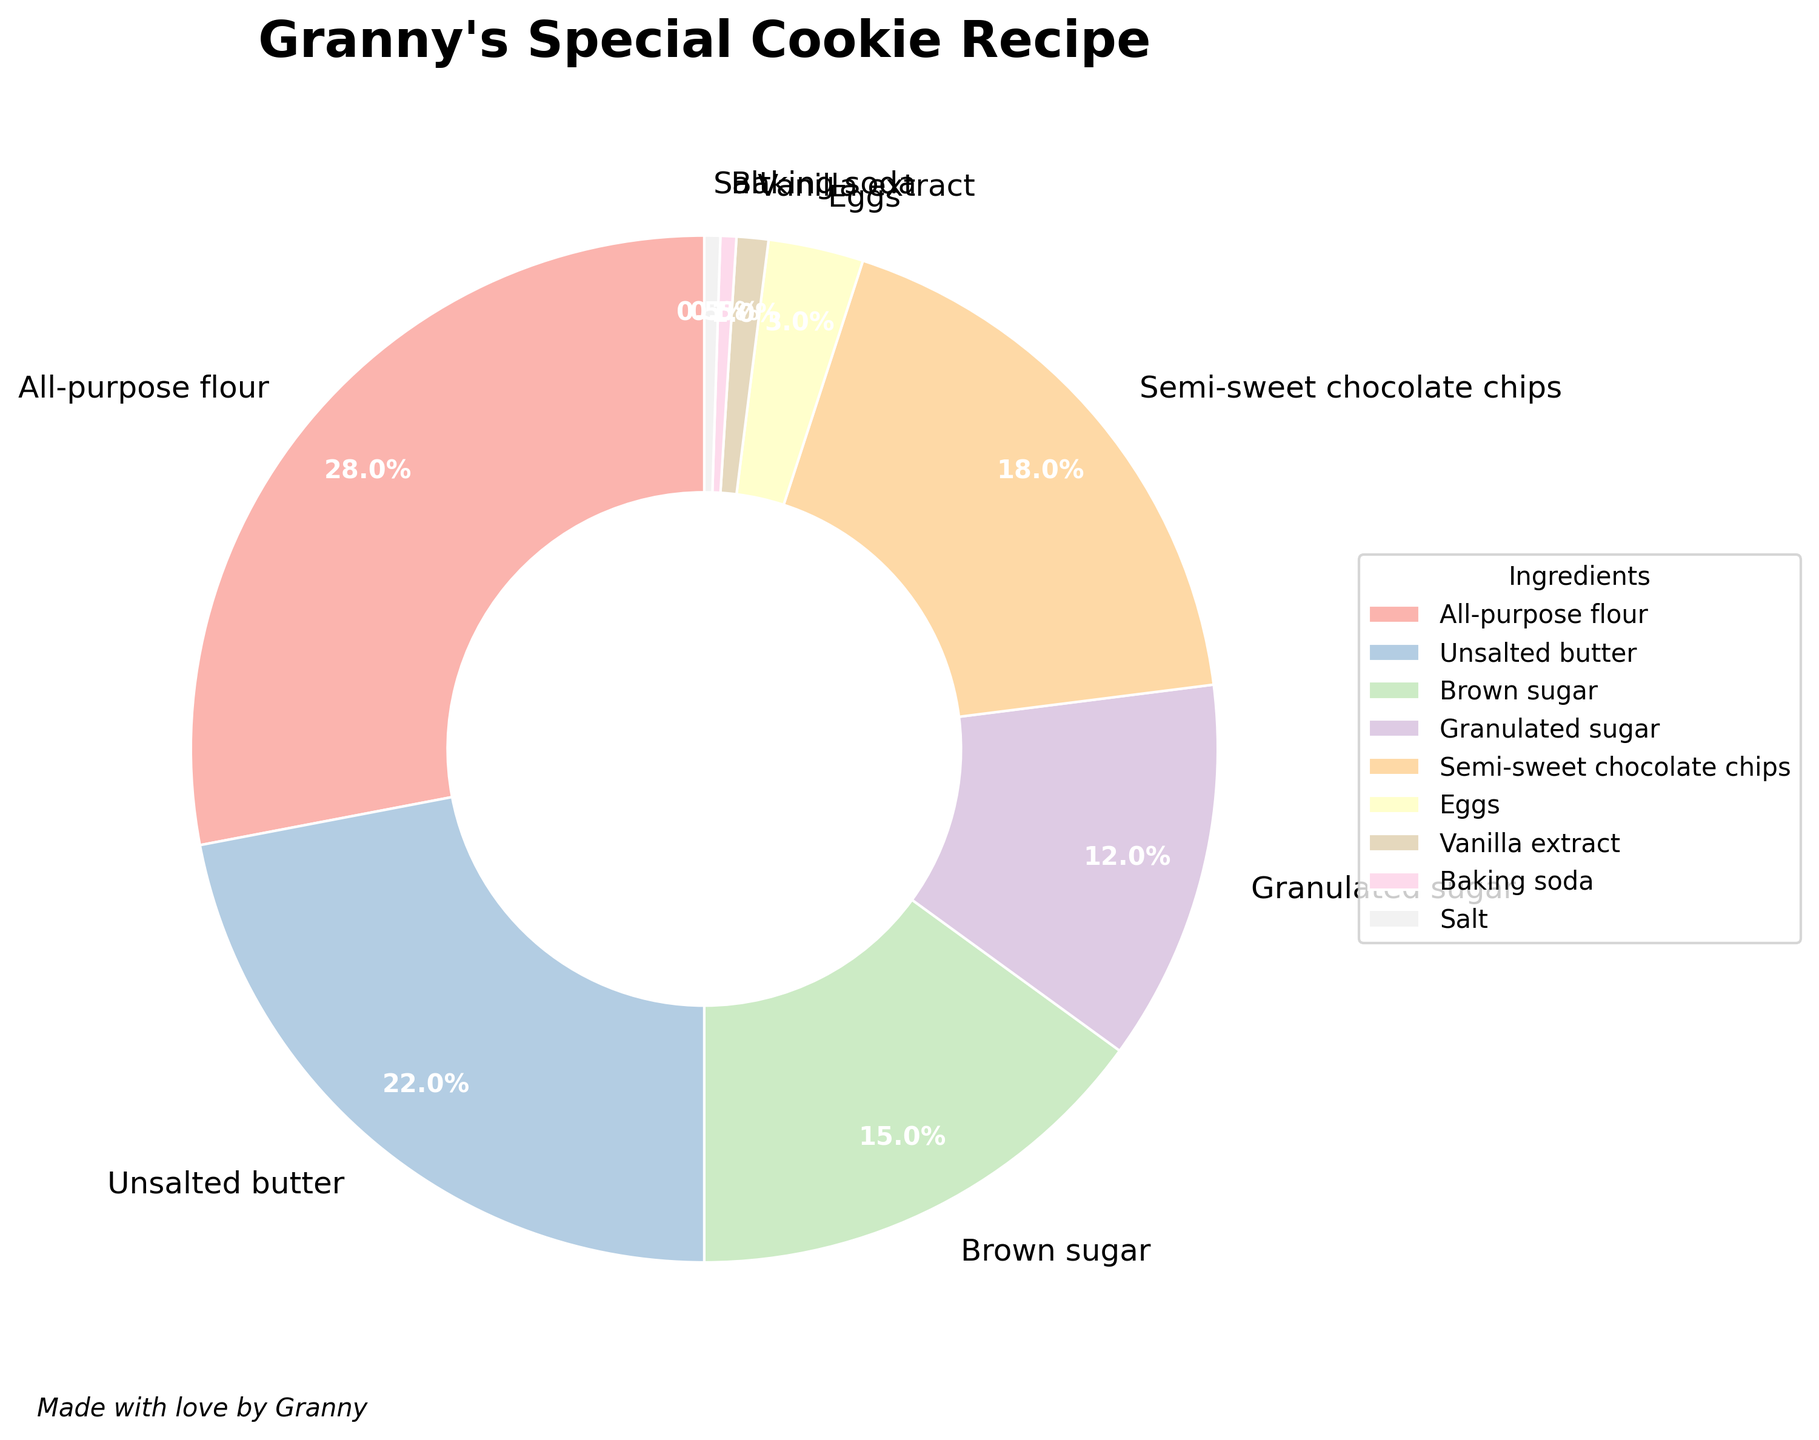What ingredient takes up the largest portion in Granny's special cookie recipe? By observing the pie chart, the sector representing the largest percentage corresponds to the ingredient with the highest proportion. In this case, it is all-purpose flour with 28%.
Answer: All-purpose flour Which is more by percentage, granulated sugar or eggs? By comparing the percentages shown in the pie chart, granulated sugar is 12%, while eggs are 3%. Therefore, granulated sugar has a higher percentage than eggs.
Answer: Granulated sugar What are the total percentages of all-purpose flour and semi-sweet chocolate chips combined? To find the total, add the percentage of all-purpose flour (28%) to that of semi-sweet chocolate chips (18%). The sum is 28 + 18 = 46%.
Answer: 46% How does the percentage of brown sugar compare to the percentage of granulated sugar? By looking at the pie chart, the percentage for brown sugar is 15%, whereas for granulated sugar, it is 12%. Hence, brown sugar has a higher percentage than granulated sugar.
Answer: Brown sugar is higher If you combine the percentages of unsalted butter, brown sugar, and granulated sugar, how much of the total composition do they form? Add the percentages of unsalted butter (22%), brown sugar (15%), and granulated sugar (12%). The total is 22 + 15 + 12 = 49%.
Answer: 49% What is the combined percentage of ingredients that each make up less than 5% of the recipe? According to the pie chart, the ingredients that form less than 5% are eggs (3%), vanilla extract (1%), baking soda (0.5%), and salt (0.5%). Their combined percentage is 3 + 1 + 0.5 + 0.5 = 5%.
Answer: 5% Which ingredient is represented with the smallest slice in the pie chart? By examining the slices, both baking soda and salt have the smallest portions at 0.5% each.
Answer: Baking soda and salt (tie) How do the combined percentages of semi-sweet chocolate chips and brown sugar compare to the percentage of all-purpose flour? First, add the percentages of semi-sweet chocolate chips (18%) and brown sugar (15%) which equals 33%. Then compare this to the 28% of all-purpose flour. The combined percentage of the two ingredients is greater than that of all-purpose flour.
Answer: Combined is greater Which color corresponds to vanilla extract in the plot? By identifying the color sectors of the pie chart, vanilla extract is labeled with the color associated with its slice.
Answer: Light pastel color (exact identification depends on color palette) 